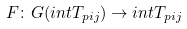Convert formula to latex. <formula><loc_0><loc_0><loc_500><loc_500>F \colon G ( i n t T _ { p i j } ) \to i n t T _ { p i j }</formula> 